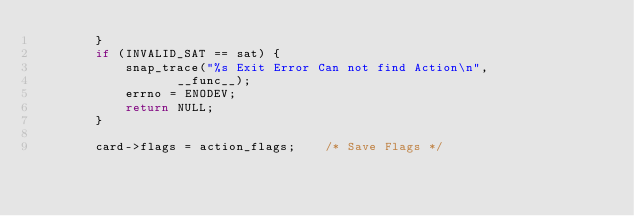Convert code to text. <code><loc_0><loc_0><loc_500><loc_500><_C_>		}
		if (INVALID_SAT == sat) {
			snap_trace("%s Exit Error Can not find Action\n",
				   __func__);
			errno = ENODEV;
			return NULL;
		}

		card->flags = action_flags;    /* Save Flags */</code> 